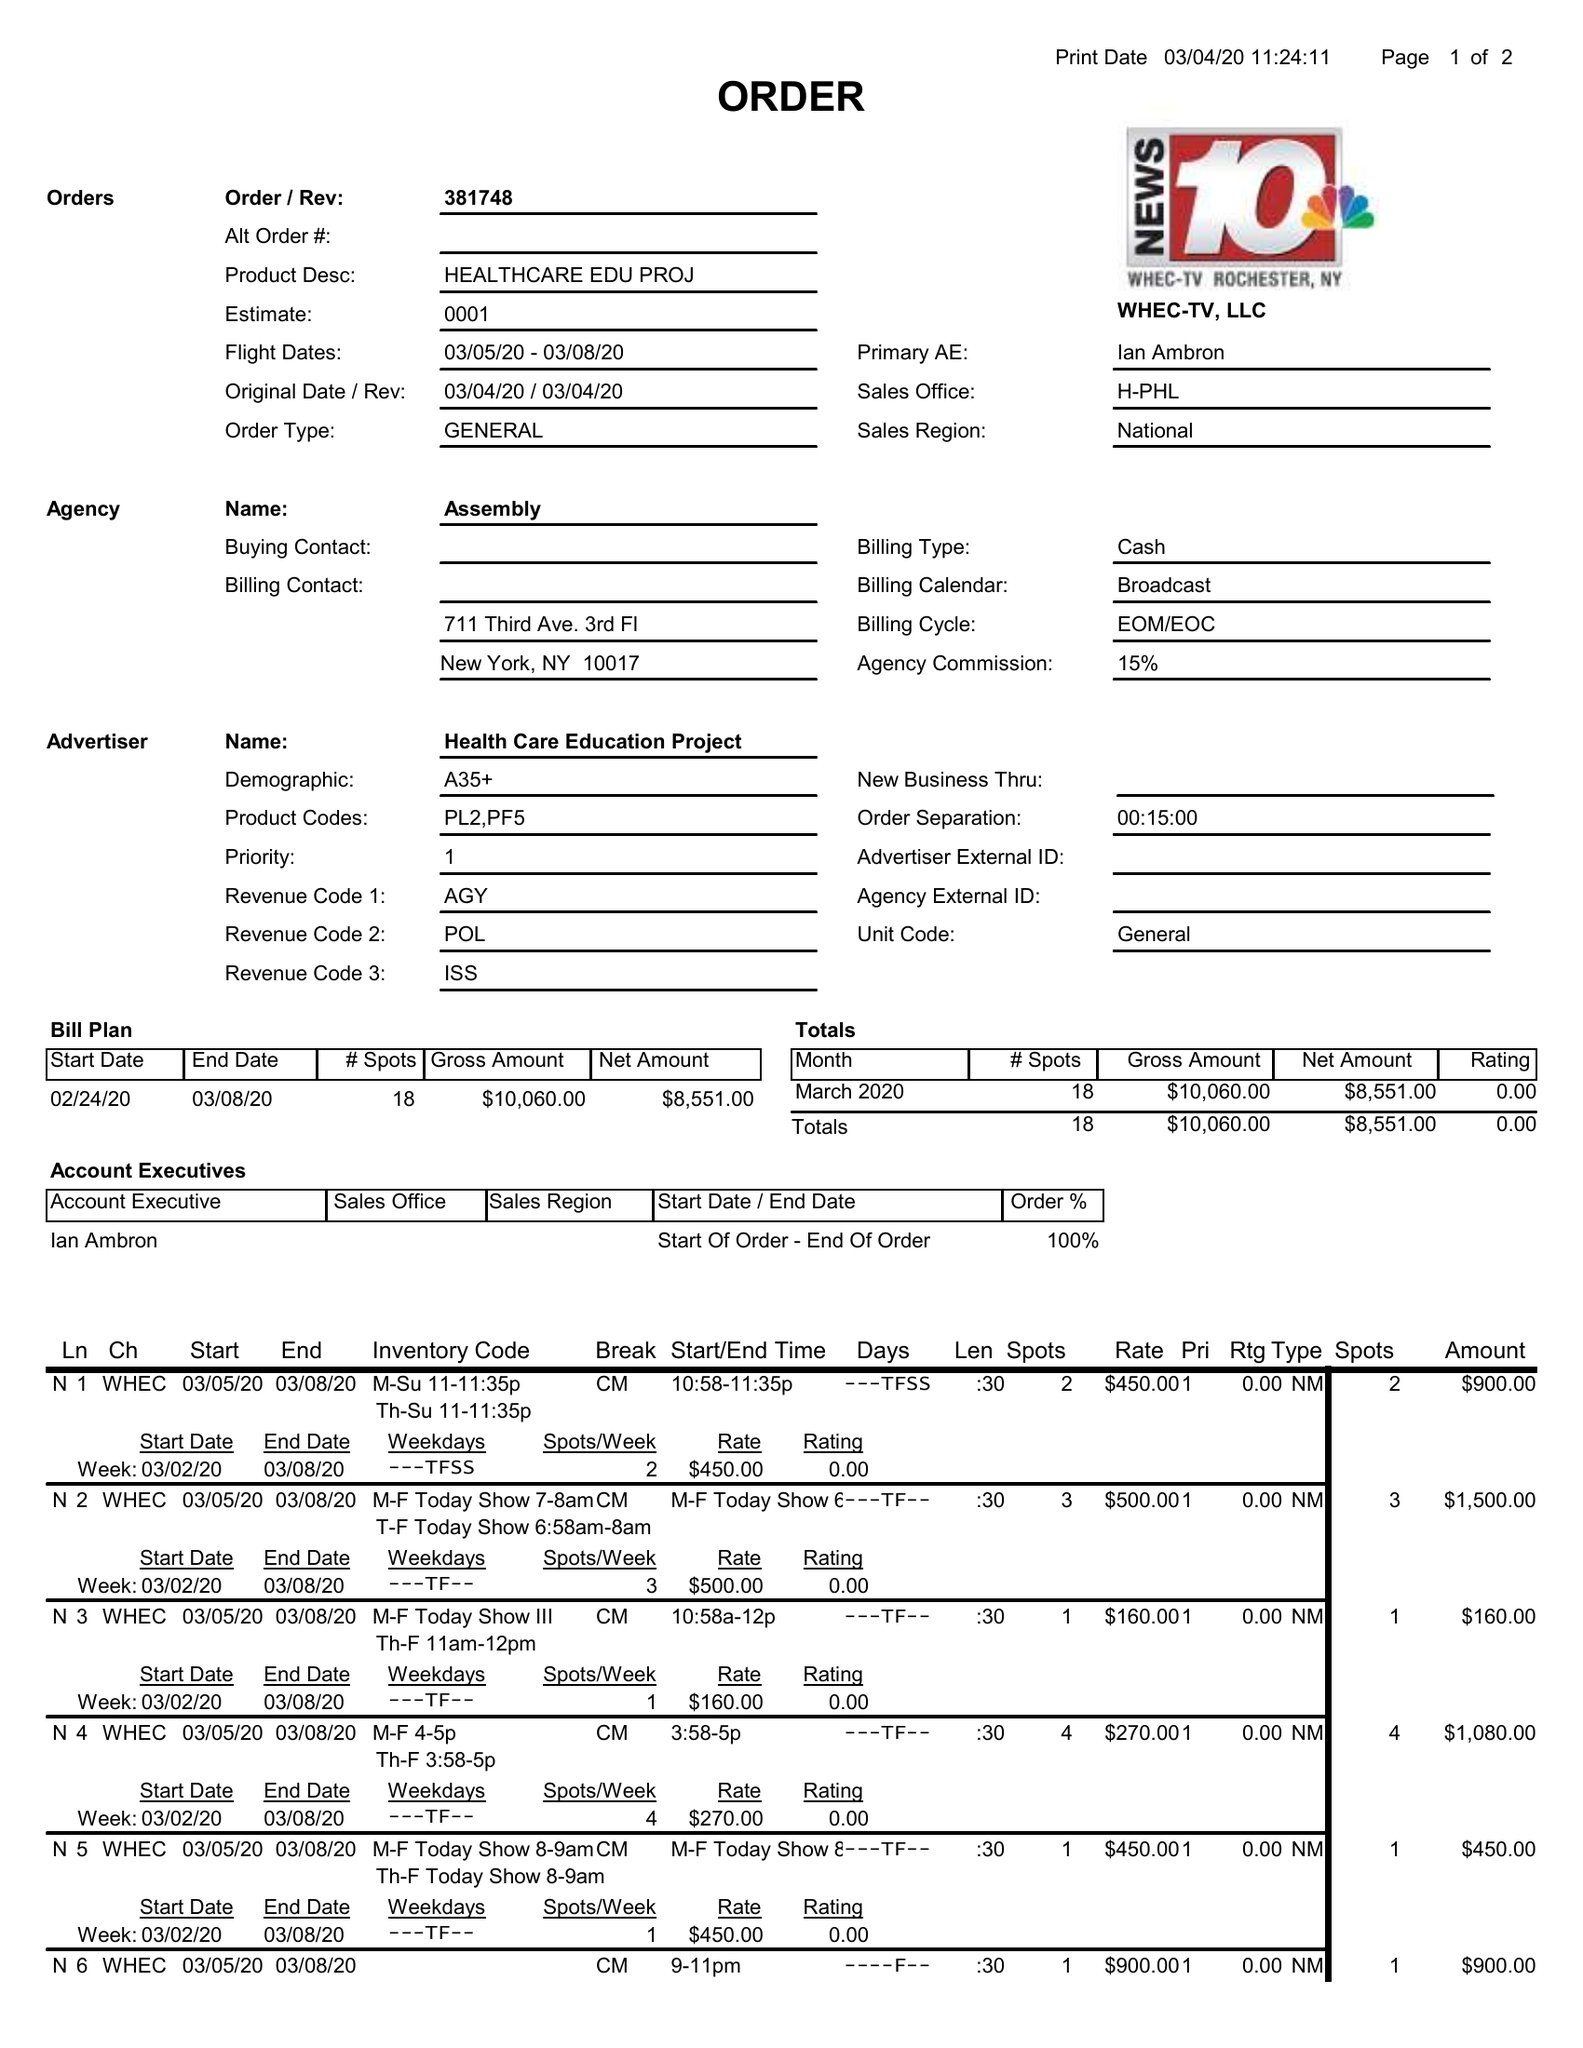What is the value for the contract_num?
Answer the question using a single word or phrase. 381748 